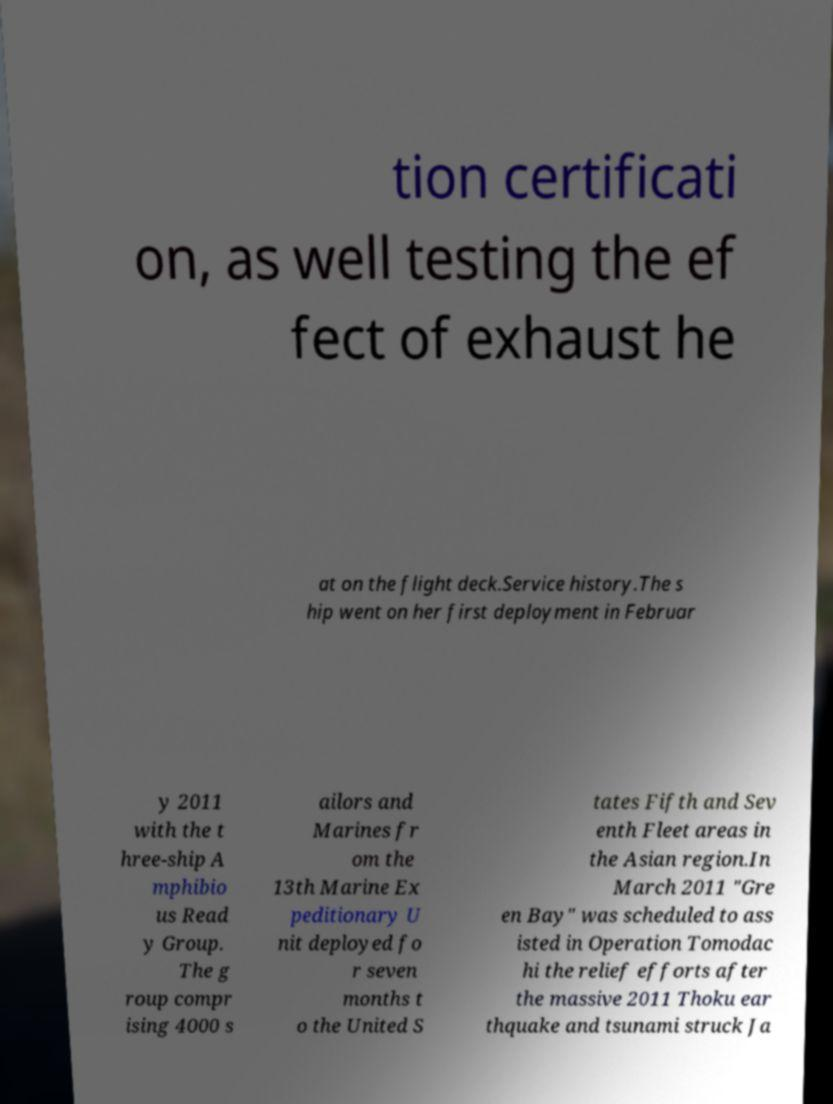Could you extract and type out the text from this image? tion certificati on, as well testing the ef fect of exhaust he at on the flight deck.Service history.The s hip went on her first deployment in Februar y 2011 with the t hree-ship A mphibio us Read y Group. The g roup compr ising 4000 s ailors and Marines fr om the 13th Marine Ex peditionary U nit deployed fo r seven months t o the United S tates Fifth and Sev enth Fleet areas in the Asian region.In March 2011 "Gre en Bay" was scheduled to ass isted in Operation Tomodac hi the relief efforts after the massive 2011 Thoku ear thquake and tsunami struck Ja 